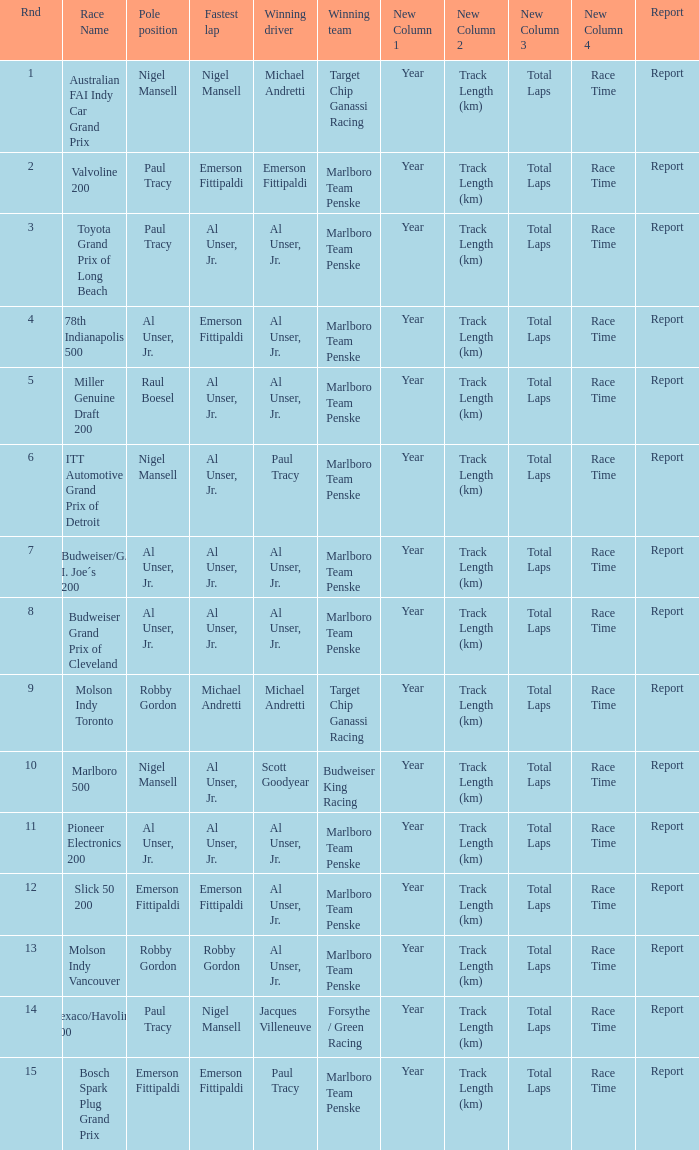What's the report of the race won by Michael Andretti, with Nigel Mansell driving the fastest lap? Report. 